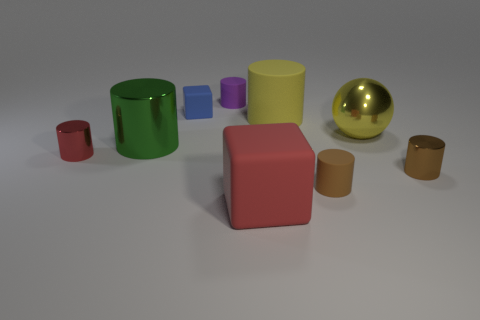Subtract 1 cylinders. How many cylinders are left? 5 Subtract all tiny brown rubber cylinders. How many cylinders are left? 5 Subtract all brown cylinders. How many cylinders are left? 4 Subtract all yellow cylinders. Subtract all red spheres. How many cylinders are left? 5 Add 1 yellow matte cubes. How many objects exist? 10 Subtract all spheres. How many objects are left? 8 Subtract 0 purple balls. How many objects are left? 9 Subtract all big shiny spheres. Subtract all yellow things. How many objects are left? 6 Add 2 tiny things. How many tiny things are left? 7 Add 8 brown things. How many brown things exist? 10 